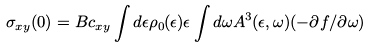Convert formula to latex. <formula><loc_0><loc_0><loc_500><loc_500>\sigma _ { x y } ( 0 ) = B c _ { x y } \int d \epsilon \rho _ { 0 } ( \epsilon ) \epsilon \int d \omega A ^ { 3 } ( \epsilon , \omega ) ( { - \partial f / \partial \omega } )</formula> 